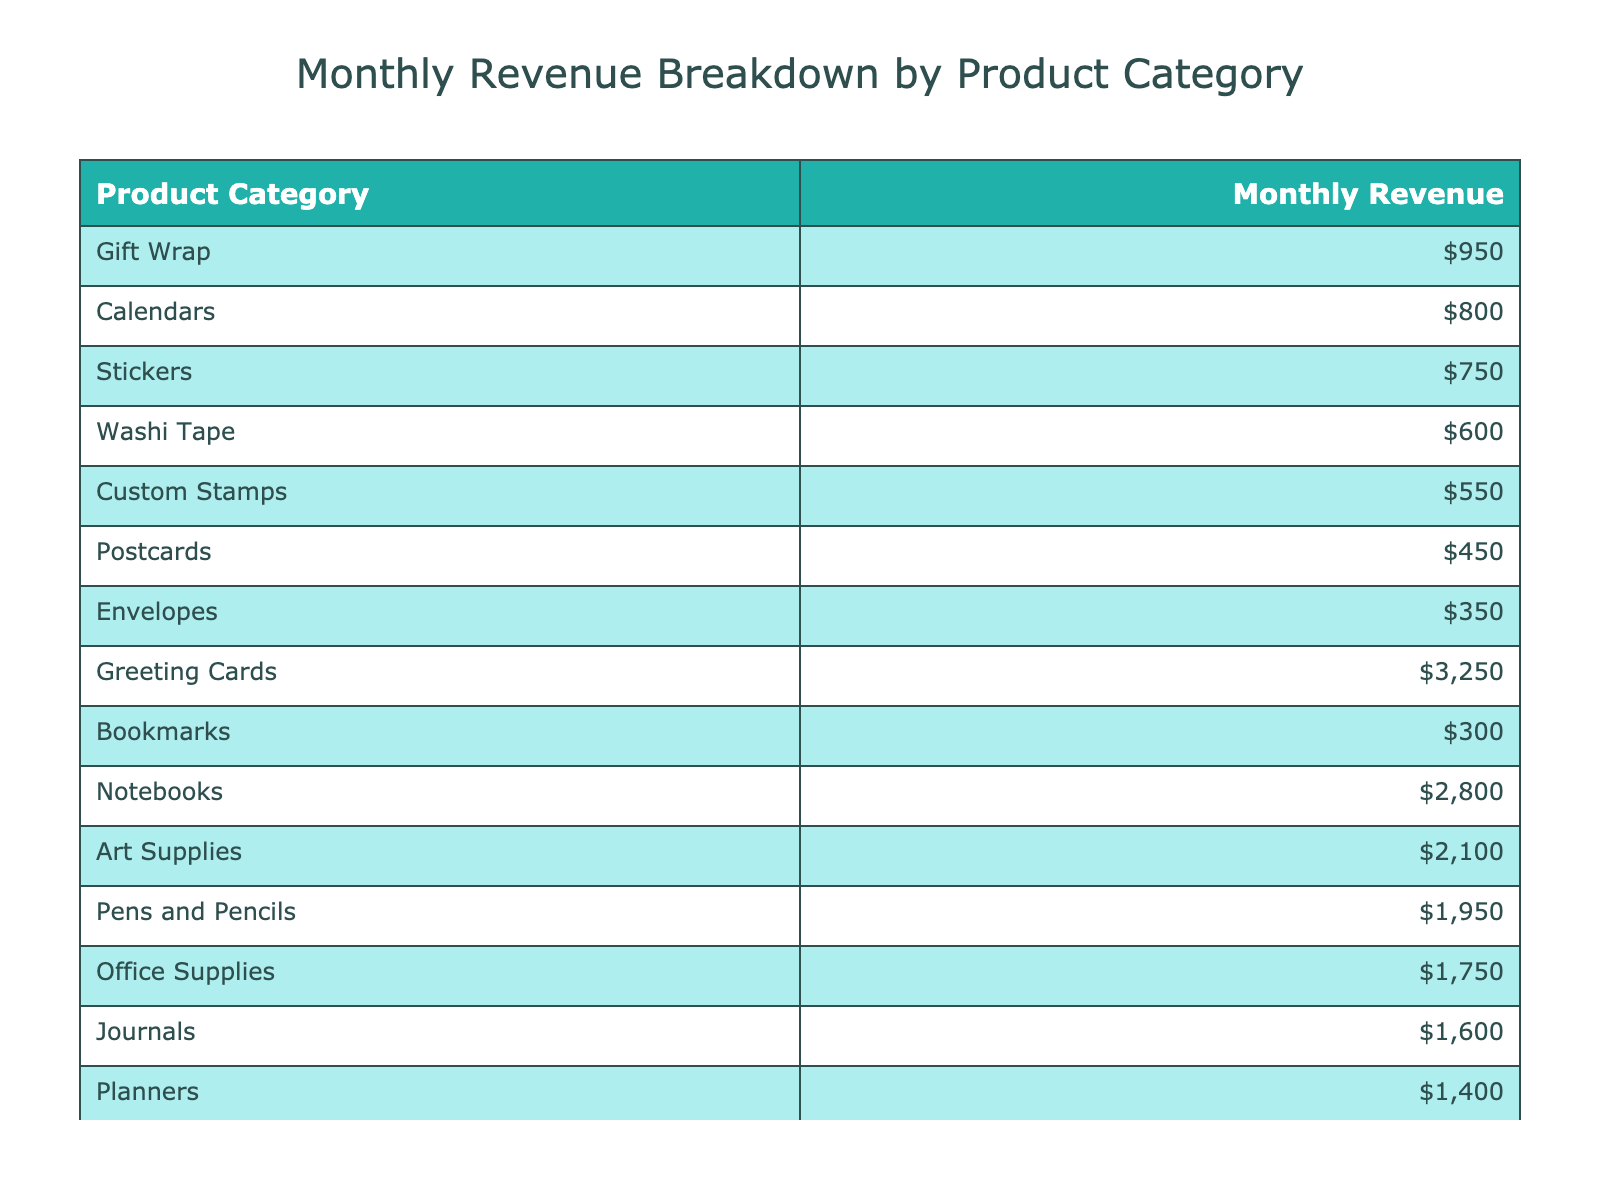What is the total monthly revenue for all product categories? To find the total revenue, sum the monthly revenues of all product categories: $3250 + $2800 + $1950 + $2100 + $1750 + $1600 + $950 + $800 + $1400 + $750 + $600 + $450 + $350 + $300 + $550 = $ 25,000
Answer: $25,000 Which product category generates the highest monthly revenue? By examining the table, the highest revenue is shown for Greeting Cards at $3250, which is clearly listed first in the sorted table.
Answer: Greeting Cards What is the average monthly revenue of all product categories? To calculate the average, sum the monthly revenues ($25,000 as found previously) and then divide by the number of categories (15): $25,000 / 15 = $1666.67.
Answer: $1,666.67 Is there any product category that generates less than $500 in monthly revenue? Checking each category, the lowest revenue is for Postcards at $450, which is indeed less than $500.
Answer: Yes What is the difference in revenue between Notebooks and Journals? The revenue for Notebooks is $2800 and for Journals it is $1600. The difference is $2800 - $1600 = $1200.
Answer: $1,200 Which product categories generate more than $1,500 in monthly revenue? Referring to the table, the categories generating more than $1,500 are Greeting Cards, Notebooks, Pens and Pencils, Art Supplies, and Planners.
Answer: Greeting Cards, Notebooks, Pens and Pencils, Art Supplies, Planners How much revenue do the combined categories of Gift Wrap, Stickers, and Washi Tape generate monthly? The monthly revenues for these categories are $950 (Gift Wrap), $750 (Stickers), and $600 (Washi Tape). Adding these gives $950 + $750 + $600 = $2300.
Answer: $2,300 If only the top three categories were considered, what percentage of total revenue would they represent? The top three categories (Greeting Cards, Notebooks, and Pens and Pencils) generate $3250, $2800, and $1950 respectively. Their sum is $3250 + $2800 + $1950 = $8000. The percentage of total revenue ($25,000) is ($8000 / $25,000) * 100 = 32%.
Answer: 32% Are there any product categories with revenues below $1,000? Checking the table shows that Envelopes ($350), Bookmarks ($300), Custom Stamps ($550), and Washi Tape ($600) all have revenues below $1,000.
Answer: Yes What is the revenue from the combination of Office Supplies and Calendars? The revenue for Office Supplies is $1750 and for Calendars is $800. Therefore, their combined revenue is $1750 + $800 = $2550.
Answer: $2,550 